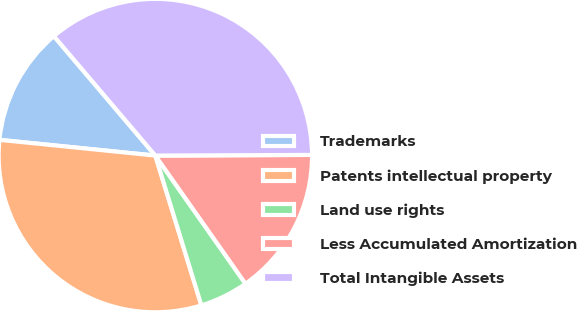<chart> <loc_0><loc_0><loc_500><loc_500><pie_chart><fcel>Trademarks<fcel>Patents intellectual property<fcel>Land use rights<fcel>Less Accumulated Amortization<fcel>Total Intangible Assets<nl><fcel>12.19%<fcel>31.35%<fcel>5.01%<fcel>15.31%<fcel>36.14%<nl></chart> 